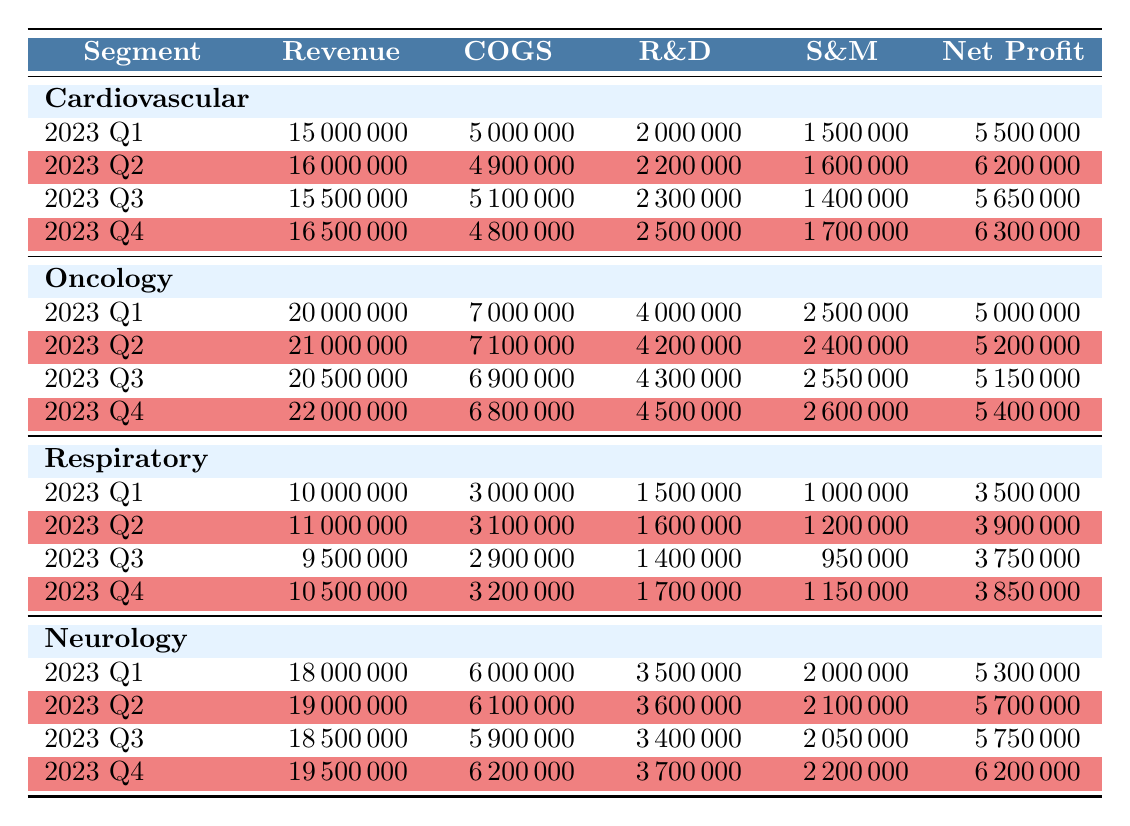What was the highest revenue recorded in the Oncology segment? In the Oncology segment, I need to look at the revenue figures across the four quarters. The revenues for the four quarters are: 20000000 (Q1), 21000000 (Q2), 20500000 (Q3), and 22000000 (Q4). The highest among these is 22000000.
Answer: 22000000 What is the net profit of the Cardiovascular segment in 2023 Q3? The net profit for the Cardiovascular segment in 2023 Q3 is directly listed in the table, which shows a value of 5650000.
Answer: 5650000 Is the total revenue for the Neurology segment higher than that of the Respiratory segment in 2023 Q2? The total revenue for Neurology in 2023 Q2 is 19000000, while for Respiratory, it is 11000000. Since 19000000 is greater than 11000000, the statement is true.
Answer: Yes What is the average net profit for the Respiratory segment across all four quarters? To find the average net profit, I first sum the net profits: 3500000 (Q1) + 3900000 (Q2) + 3750000 (Q3) + 3850000 (Q4) = 15000000. There are four quarters, so the average net profit is 15000000 / 4 = 3750000.
Answer: 3750000 Which quarter had the lowest cost of goods sold (COGS) for the Cardiovascular segment? For the Cardiovascular segment, the COGS figures for each quarter are: 5000000 (Q1), 4900000 (Q2), 5100000 (Q3), and 4800000 (Q4). The lowest COGS value is 4800000, which occurred in Q4.
Answer: Q4 How much did research and development (R&D) expenses change from Q1 to Q4 in the Neurology segment? The R&D expenses in the Neurology segment are 3500000 (Q1) and 3700000 (Q4). The change is calculated as 3700000 - 3500000 = 200000.
Answer: 200000 Did the net profit in the Oncology segment decrease from Q1 to Q3? The net profits for Oncology across the quarters are: 5000000 (Q1), 5200000 (Q2), and 5150000 (Q3). Comparing Q1 and Q3, 5000000 < 5150000 shows that the net profit increased, so the statement is false.
Answer: No What was the cumulative revenue for the Respiratory segment for all quarters of 2023? To find the cumulative revenue, I sum the revenues: 10000000 (Q1) + 11000000 (Q2) + 9500000 (Q3) + 10500000 (Q4) = 41000000.
Answer: 41000000 